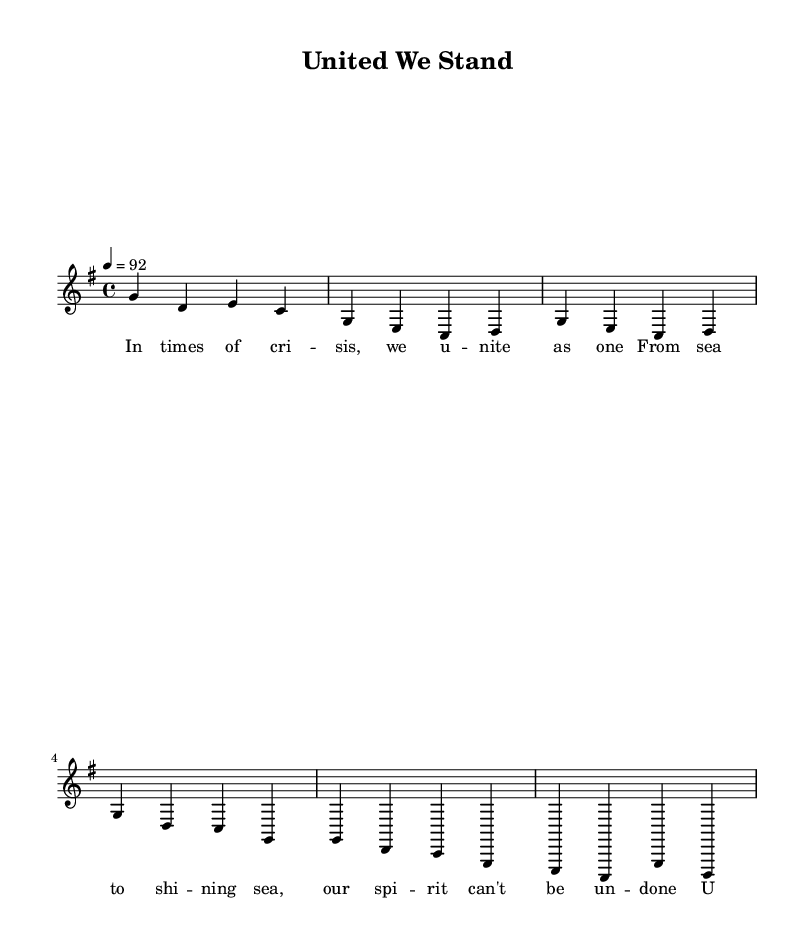What is the key signature of this music? The key signature is G major, which has one sharp (F#). This information is generally found at the beginning of the staff in sheet music.
Answer: G major What is the time signature of this music? The time signature is 4/4, indicating there are four beats in a measure and that a quarter note gets one beat. This information is typically stated right after the key signature.
Answer: 4/4 What is the tempo marking for this piece? The tempo marking indicates a speed of 92 beats per minute, which is noted with the instruction "4 = 92". This tells performers how fast to play the piece.
Answer: 92 How many measures are in the provided melody? The melody consists of five measures, which can be counted by the vertical bar lines that separate them in the sheet music.
Answer: 5 What sections make up the song? The song is divided into at least three sections: intro, verse, and chorus, as indicated in the melodic structure. This division is common in rap and helps organize the content.
Answer: Intro, Verse, Chorus What is the main theme celebrated in this rap? The rap celebrates American values and unity in times of crisis, which is reflected in the lyrics emphasizing unity and resilience. This thematic focus is typical of patriotic music.
Answer: Unity 